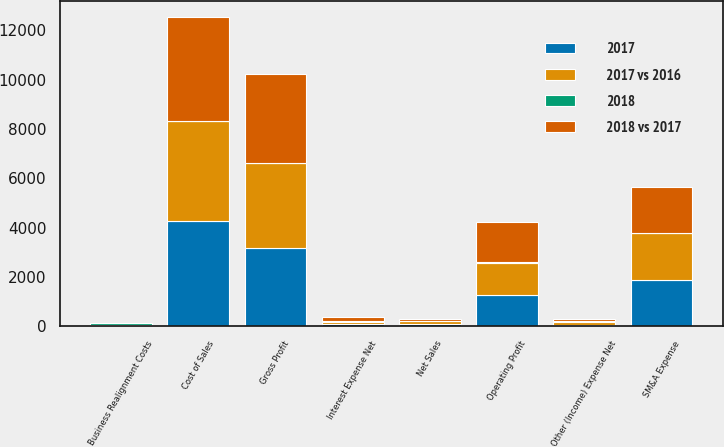<chart> <loc_0><loc_0><loc_500><loc_500><stacked_bar_chart><ecel><fcel>Net Sales<fcel>Cost of Sales<fcel>Gross Profit<fcel>SM&A Expense<fcel>Business Realignment Costs<fcel>Operating Profit<fcel>Interest Expense Net<fcel>Other (Income) Expense Net<nl><fcel>2018 vs 2017<fcel>98.3<fcel>4215.7<fcel>3575.4<fcel>1874.8<fcel>19.1<fcel>1623.8<fcel>138.8<fcel>74.8<nl><fcel>2017 vs 2016<fcel>98.3<fcel>4060<fcel>3455.4<fcel>1885.5<fcel>47.8<fcel>1313.4<fcel>98.3<fcel>104.4<nl><fcel>2017<fcel>98.3<fcel>4270.6<fcel>3169.6<fcel>1891.3<fcel>18.9<fcel>1255.2<fcel>90.2<fcel>65.6<nl><fcel>2018<fcel>3.7<fcel>3.8<fcel>3.5<fcel>0.6<fcel>60<fcel>23.6<fcel>41.3<fcel>28.4<nl></chart> 